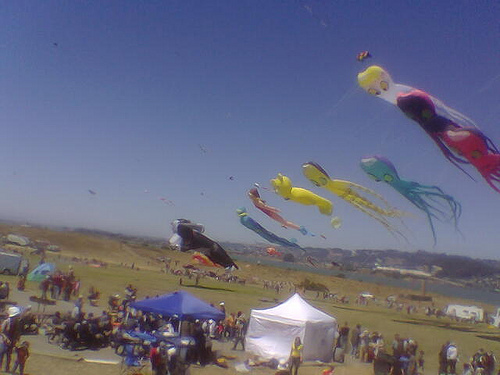Could you tell me more about the people attending this event? Certainly! The people attending the event seem to be a diverse crowd of all ages, likely comprised of local families, kite enthusiasts, and possibly tourists. The casual attire and relaxed posture of many individuals suggest a leisurely, community-focused atmosphere where attendees come together to enjoy the shared experience of kite flying.  Are there any safety considerations visible in the image for such an event? While the specific safety measures are not clearly visible in the image, standard considerations for a kite festival would include keeping a safe distance between kite flyers to avoid tangled lines, staying alert for kites that might descend suddenly, and designating clear areas for spectators away from the kite flying zones to prevent accidents.  What impact does such an event have on the community? Events like this kite festival have a positive impact on the community by providing a space for recreational and cultural expression. They encourage outdoor activity, foster social connections among attendees, support local vendors and artists, and contribute to community pride and tradition. Moreover, such events can be an opportunity for local businesses to gain exposure and for the community to raise awareness about various causes. 